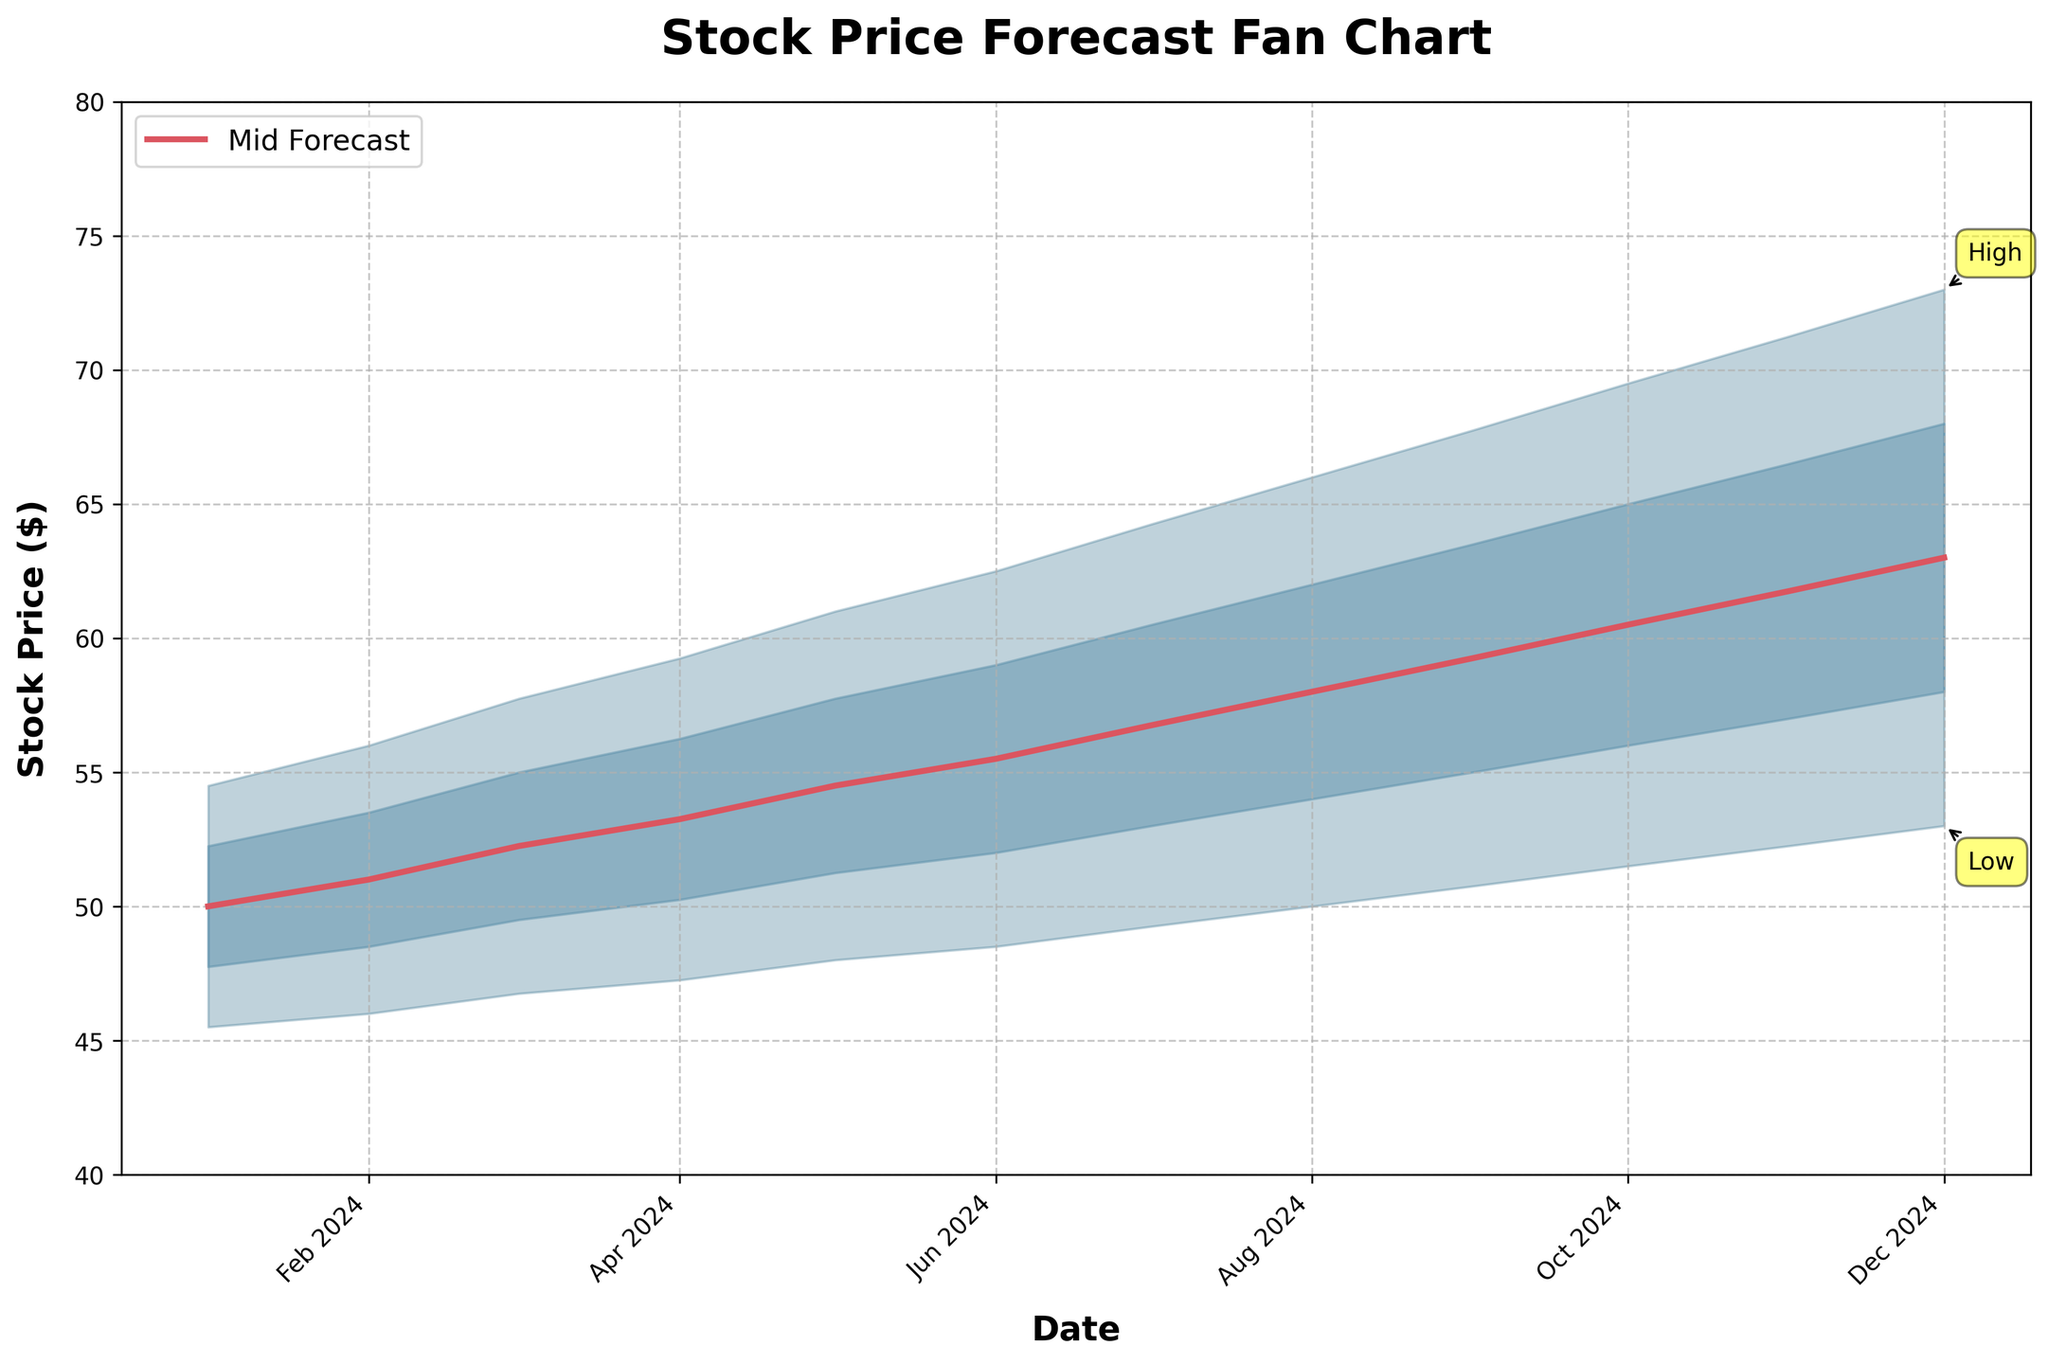What is the mid forecast price in Dec 2024? Look at the Mid column and find the corresponding value for Dec 2024.
Answer: 63.00 What is the range between the low and high forecasts for Mar 2024? Subtract the low forecast value from the high forecast value for Mar 2024. The high is 57.75 and the low is 46.75, so the range is 57.75 - 46.75.
Answer: 11.00 In which month is the mid forecast price expected to exceed $60 for the first time? Find the first month where the value in the Mid column exceeds 60.00. It occurs in Oct 2024.
Answer: Oct 2024 How much does the low-mid forecast price change from Jun 2024 to Jul 2024? Subtract the low-mid forecast for Jun 2024 from the low-mid forecast for Jul 2024. The values are 52.00 and 53.00, so the difference is 53.00 - 52.00.
Answer: 1.00 Which month shows the smallest gap between the low forecast and the mid forecast? Calculate the difference between the low and mid forecast for each month and identify the smallest. The differences are: Jan: 4.50, Feb: 5.00, Mar: 5.50, Apr: 6.00, May: 6.50, Jun: 7.00, Jul: 7.50, Aug: 8.00, Sep: 8.50, Oct: 9.00, Nov: 9.50, Dec: 10.00. Therefore, the smallest gap is in Jan 2024.
Answer: Jan 2024 How does the high forecast price change from Sep 2024 to Dec 2024? Compare the high forecast price for Sep and Dec 2024. The prices are 67.75 and 73.00 respectively. The change is 73.00 - 67.75.
Answer: 5.25 What is the average mid forecast price over the last six months? Sum the mid forecast prices from Jul to Dec 2024 and divide by the number of months. The sum is 56.75 + 58.00 + 59.25 + 60.50 + 61.75 + 63.00 = 359.25. Divide by 6 months to get the average: 359.25 / 6.
Answer: 59.88 Which month has the steepest increase in the mid forecast price compared to the previous month? Calculate the month-over-month increase in mid forecast and identify the highest. Increases: Jan-Feb: 1.00, Feb-Mar: 1.25, Mar-Apr: 1.00, Apr-May: 1.25, May-Jun: 1.00, Jun-Jul: 1.25, Jul-Aug: 1.25, Aug-Sep: 1.25, Sep-Oct: 1.25, Oct-Nov: 1.25, Nov-Dec: 1.25. The steepest increase occurred equally across multiple months.
Answer: Feb 2024 (or Mar, May, Jul, Aug, Sep, Oct, Nov, Dec) What is the median value of the mid-forecast prices from Jan 2024 to Dec 2024? List the mid forecast prices, sort them, and find the median. Values: 50.00, 51.00, 52.25, 53.25, 54.50, 55.50, 56.75, 58.00, 59.25, 60.50, 61.75, 63.00. The median of these 12 values is the average of the 6th and 7th values (55.50 and 56.75): (55.50 + 56.75) / 2.
Answer: 56.13 